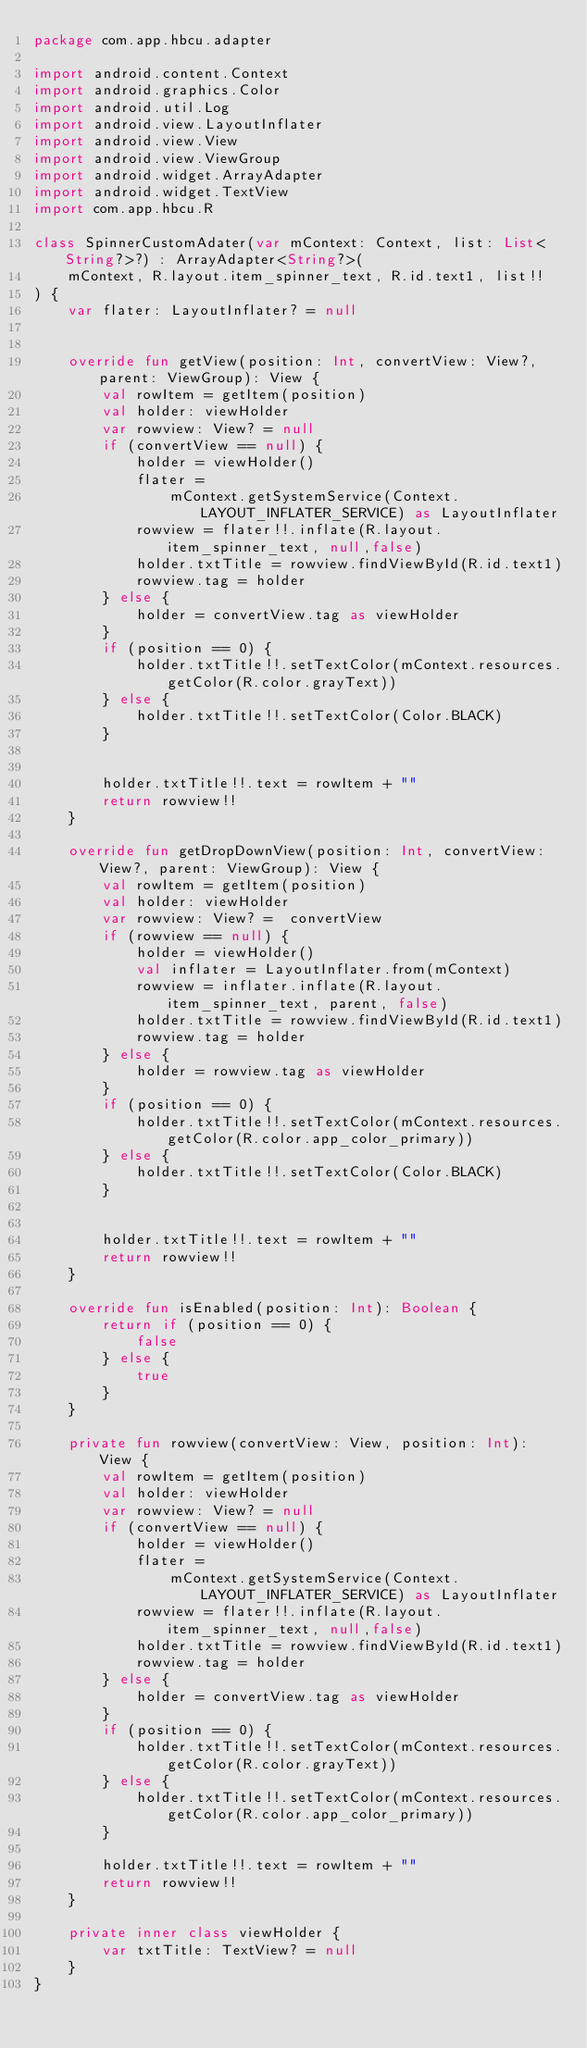<code> <loc_0><loc_0><loc_500><loc_500><_Kotlin_>package com.app.hbcu.adapter

import android.content.Context
import android.graphics.Color
import android.util.Log
import android.view.LayoutInflater
import android.view.View
import android.view.ViewGroup
import android.widget.ArrayAdapter
import android.widget.TextView
import com.app.hbcu.R

class SpinnerCustomAdater(var mContext: Context, list: List<String?>?) : ArrayAdapter<String?>(
    mContext, R.layout.item_spinner_text, R.id.text1, list!!
) {
    var flater: LayoutInflater? = null


    override fun getView(position: Int, convertView: View?, parent: ViewGroup): View {
        val rowItem = getItem(position)
        val holder: viewHolder
        var rowview: View? = null
        if (convertView == null) {
            holder = viewHolder()
            flater =
                mContext.getSystemService(Context.LAYOUT_INFLATER_SERVICE) as LayoutInflater
            rowview = flater!!.inflate(R.layout.item_spinner_text, null,false)
            holder.txtTitle = rowview.findViewById(R.id.text1)
            rowview.tag = holder
        } else {
            holder = convertView.tag as viewHolder
        }
        if (position == 0) {
            holder.txtTitle!!.setTextColor(mContext.resources.getColor(R.color.grayText))
        } else {
            holder.txtTitle!!.setTextColor(Color.BLACK)
        }


        holder.txtTitle!!.text = rowItem + ""
        return rowview!!
    }

    override fun getDropDownView(position: Int, convertView: View?, parent: ViewGroup): View {
        val rowItem = getItem(position)
        val holder: viewHolder
        var rowview: View? =  convertView
        if (rowview == null) {
            holder = viewHolder()
            val inflater = LayoutInflater.from(mContext)
            rowview = inflater.inflate(R.layout.item_spinner_text, parent, false)
            holder.txtTitle = rowview.findViewById(R.id.text1)
            rowview.tag = holder
        } else {
            holder = rowview.tag as viewHolder
        }
        if (position == 0) {
            holder.txtTitle!!.setTextColor(mContext.resources.getColor(R.color.app_color_primary))
        } else {
            holder.txtTitle!!.setTextColor(Color.BLACK)
        }


        holder.txtTitle!!.text = rowItem + ""
        return rowview!!
    }

    override fun isEnabled(position: Int): Boolean {
        return if (position == 0) {
            false
        } else {
            true
        }
    }

    private fun rowview(convertView: View, position: Int): View {
        val rowItem = getItem(position)
        val holder: viewHolder
        var rowview: View? = null
        if (convertView == null) {
            holder = viewHolder()
            flater =
                mContext.getSystemService(Context.LAYOUT_INFLATER_SERVICE) as LayoutInflater
            rowview = flater!!.inflate(R.layout.item_spinner_text, null,false)
            holder.txtTitle = rowview.findViewById(R.id.text1)
            rowview.tag = holder
        } else {
            holder = convertView.tag as viewHolder
        }
        if (position == 0) {
            holder.txtTitle!!.setTextColor(mContext.resources.getColor(R.color.grayText))
        } else {
            holder.txtTitle!!.setTextColor(mContext.resources.getColor(R.color.app_color_primary))
        }

        holder.txtTitle!!.text = rowItem + ""
        return rowview!!
    }

    private inner class viewHolder {
        var txtTitle: TextView? = null
    }
}</code> 